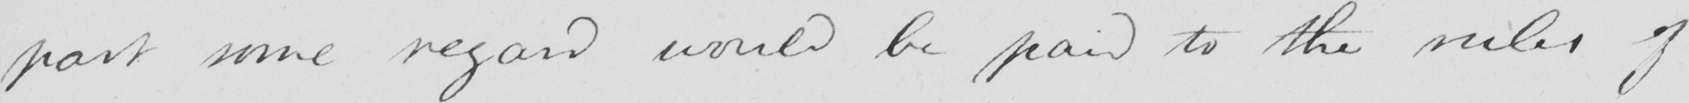Can you tell me what this handwritten text says? part some regard would be paid to the ruler of 